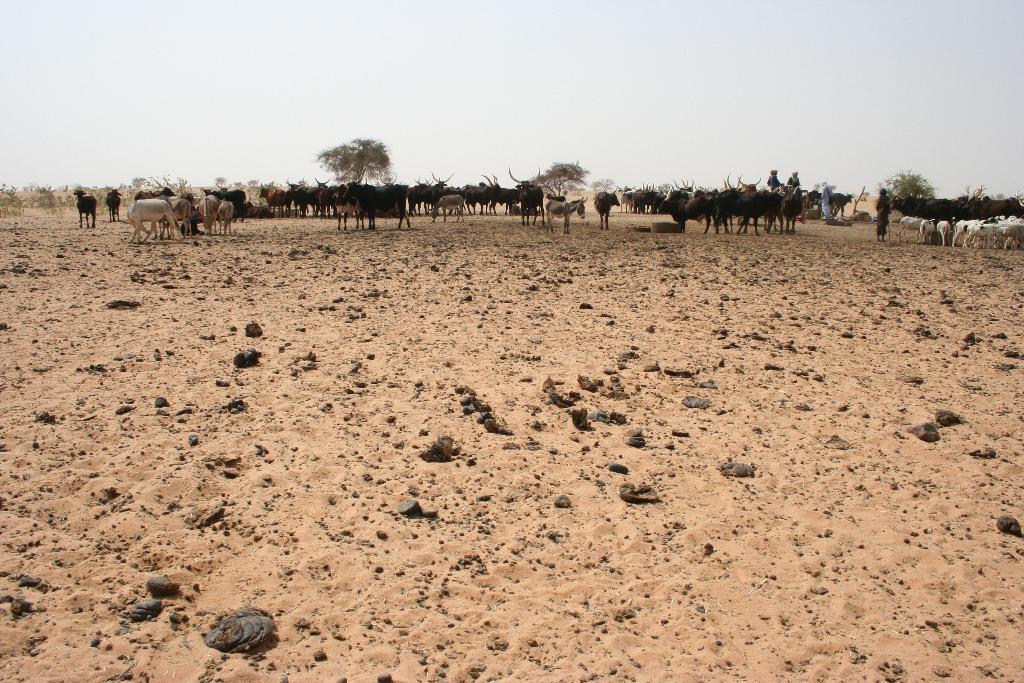How would you summarize this image in a sentence or two? In this picture I can see the animals on the surface. I can see a few people. I can see trees. I can see clouds in the sky. 